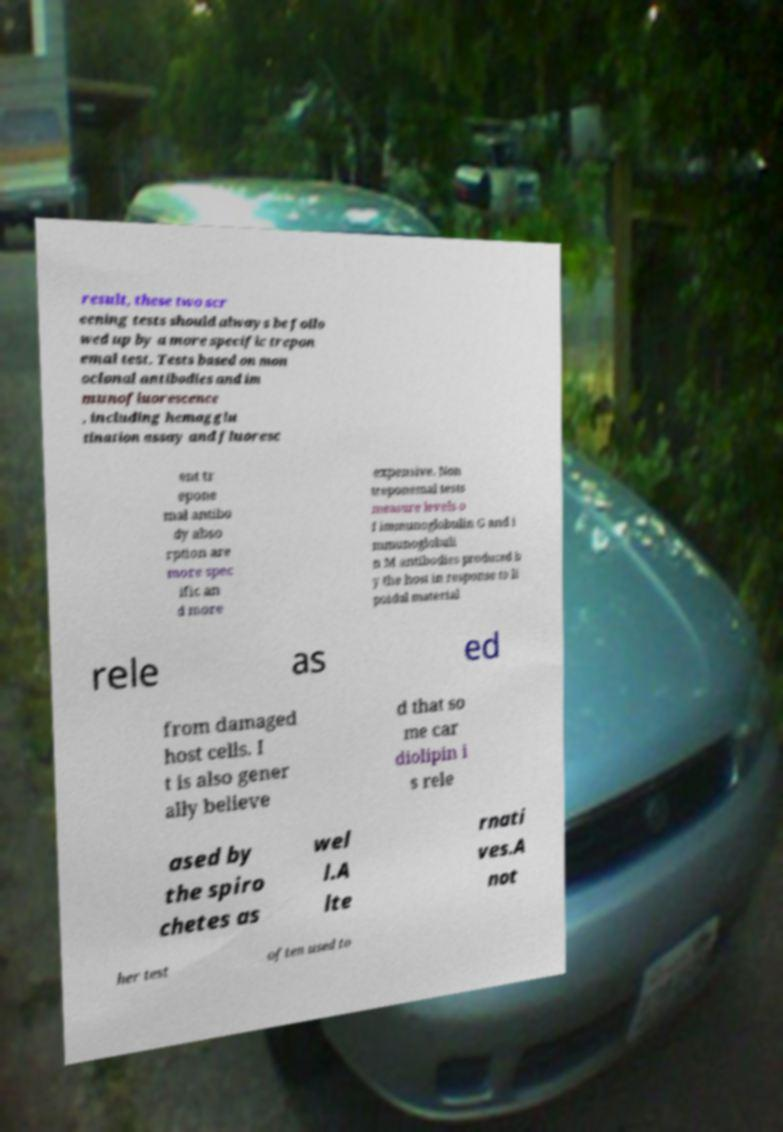Could you assist in decoding the text presented in this image and type it out clearly? result, these two scr eening tests should always be follo wed up by a more specific trepon emal test. Tests based on mon oclonal antibodies and im munofluorescence , including hemagglu tination assay and fluoresc ent tr epone mal antibo dy abso rption are more spec ific an d more expensive. Non treponemal tests measure levels o f immunoglobulin G and i mmunoglobuli n M antibodies produced b y the host in response to li poidal material rele as ed from damaged host cells. I t is also gener ally believe d that so me car diolipin i s rele ased by the spiro chetes as wel l.A lte rnati ves.A not her test often used to 